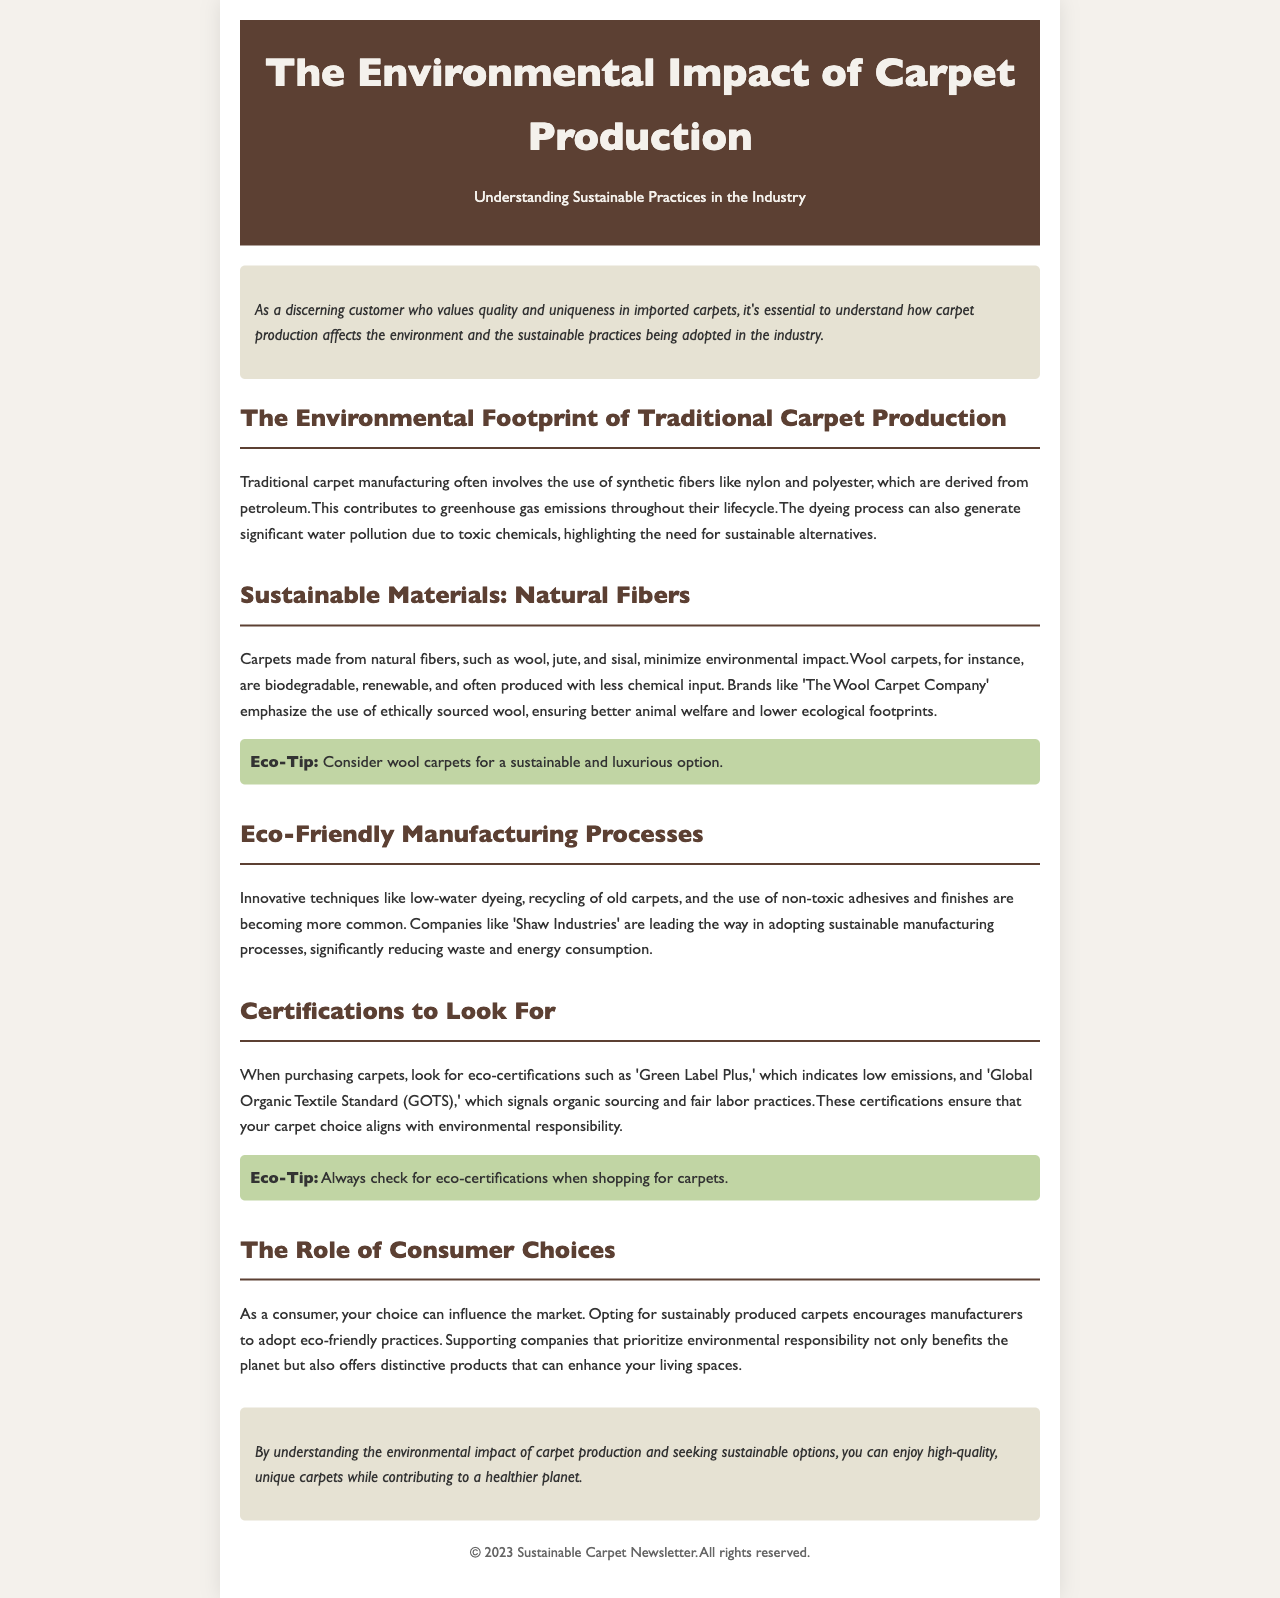What are the common synthetic fibers used in traditional carpet production? Traditional carpet production often involves synthetic fibers like nylon and polyester, which are derived from petroleum.
Answer: nylon and polyester What type of carpets are highlighted as sustainable options? The document emphasizes carpets made from natural fibers, such as wool, jute, and sisal, as sustainable options.
Answer: wool, jute, and sisal Which company is noted for using ethically sourced wool? The newsletter mentions 'The Wool Carpet Company' as a brand that emphasizes the use of ethically sourced wool.
Answer: The Wool Carpet Company What does the 'Green Label Plus' certification indicate? The 'Green Label Plus' certification indicates low emissions in carpet products, ensuring better environmental standards.
Answer: low emissions What influence do consumer choices have according to the document? The document states that consumer choices can influence the market, encouraging manufacturers to adopt eco-friendly practices.
Answer: influence the market Which manufacturing company's sustainable processes are highlighted? 'Shaw Industries' is noted for leading the way in adopting sustainable manufacturing processes, reducing waste and energy consumption.
Answer: Shaw Industries What is a suggested eco-tip for consumers shopping for carpets? The eco-tip provided suggests always checking for eco-certifications when shopping for carpets to ensure environmental responsibility.
Answer: check for eco-certifications What is the main focus of the newsletter? The newsletter primarily focuses on understanding the environmental impact of carpet production and sustainable practices in the industry.
Answer: environmental impact of carpet production 